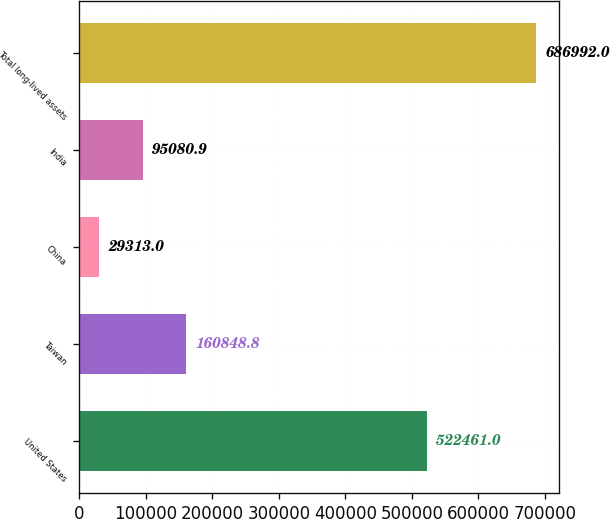<chart> <loc_0><loc_0><loc_500><loc_500><bar_chart><fcel>United States<fcel>Taiwan<fcel>China<fcel>India<fcel>Total long-lived assets<nl><fcel>522461<fcel>160849<fcel>29313<fcel>95080.9<fcel>686992<nl></chart> 